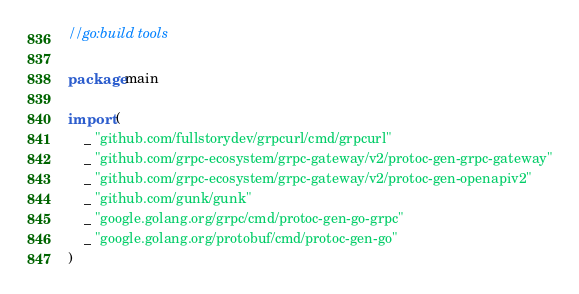<code> <loc_0><loc_0><loc_500><loc_500><_Go_>//go:build tools

package main

import (
	_ "github.com/fullstorydev/grpcurl/cmd/grpcurl"
	_ "github.com/grpc-ecosystem/grpc-gateway/v2/protoc-gen-grpc-gateway"
	_ "github.com/grpc-ecosystem/grpc-gateway/v2/protoc-gen-openapiv2"
	_ "github.com/gunk/gunk"
	_ "google.golang.org/grpc/cmd/protoc-gen-go-grpc"
	_ "google.golang.org/protobuf/cmd/protoc-gen-go"
)
</code> 